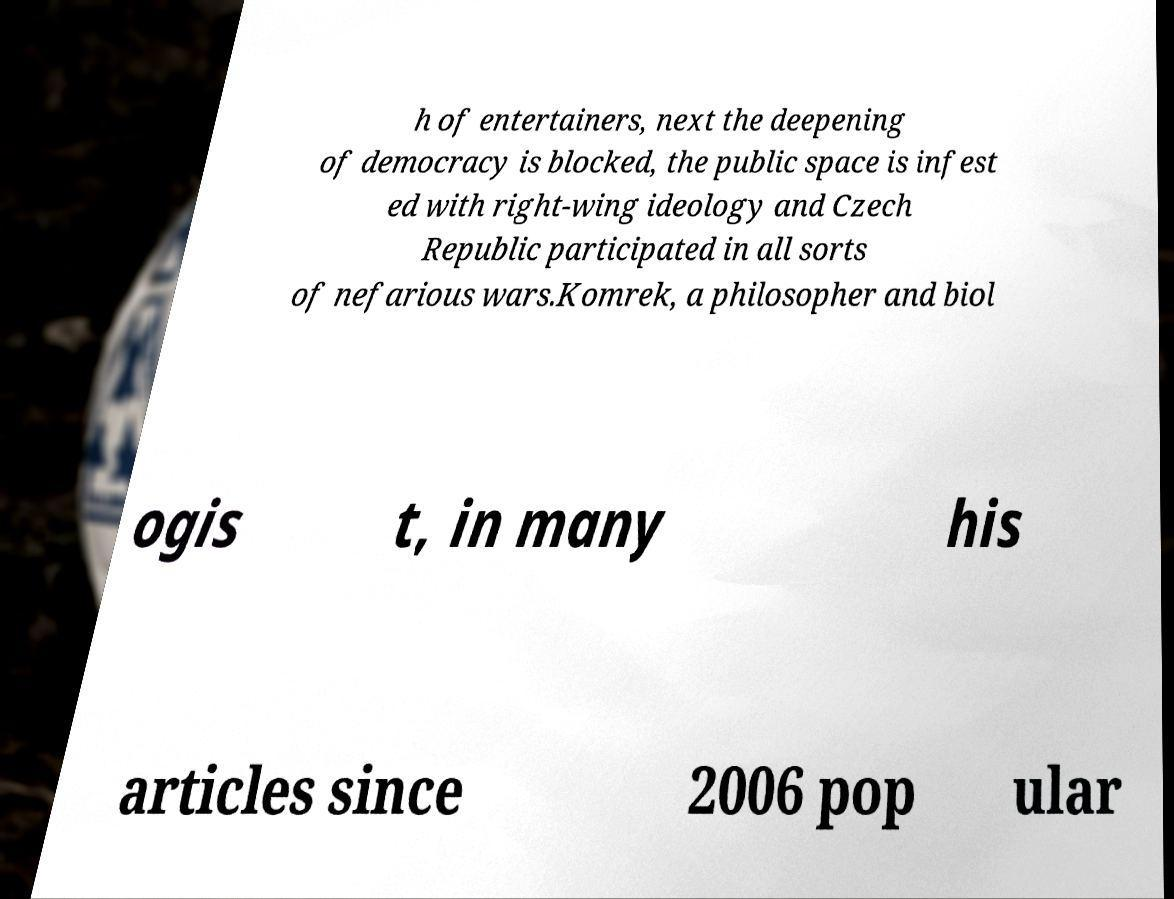I need the written content from this picture converted into text. Can you do that? h of entertainers, next the deepening of democracy is blocked, the public space is infest ed with right-wing ideology and Czech Republic participated in all sorts of nefarious wars.Komrek, a philosopher and biol ogis t, in many his articles since 2006 pop ular 